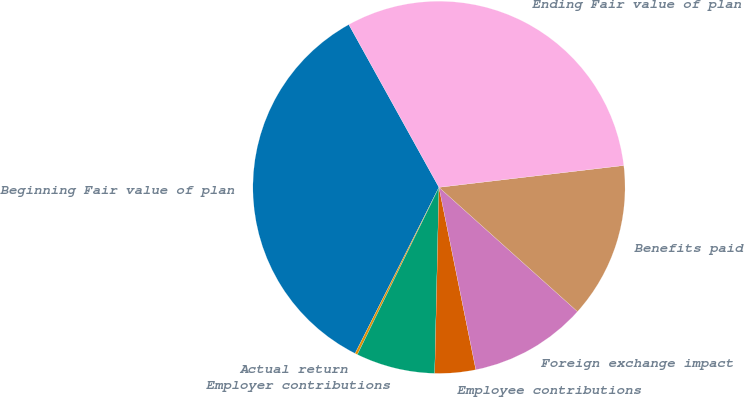<chart> <loc_0><loc_0><loc_500><loc_500><pie_chart><fcel>Beginning Fair value of plan<fcel>Actual return<fcel>Employer contributions<fcel>Employee contributions<fcel>Foreign exchange impact<fcel>Benefits paid<fcel>Ending Fair value of plan<nl><fcel>34.51%<fcel>0.22%<fcel>6.86%<fcel>3.54%<fcel>10.19%<fcel>13.51%<fcel>31.18%<nl></chart> 